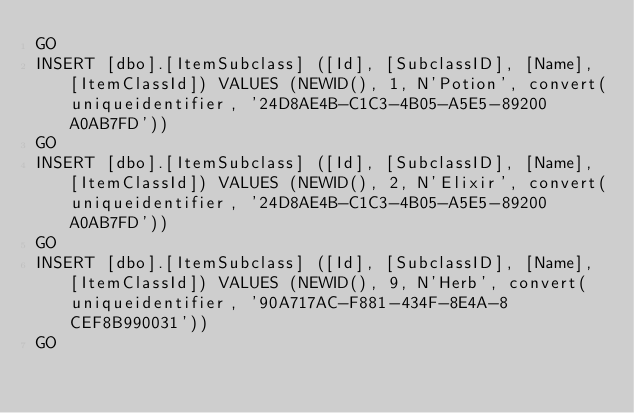<code> <loc_0><loc_0><loc_500><loc_500><_SQL_>GO
INSERT [dbo].[ItemSubclass] ([Id], [SubclassID], [Name], [ItemClassId]) VALUES (NEWID(), 1, N'Potion', convert(uniqueidentifier, '24D8AE4B-C1C3-4B05-A5E5-89200A0AB7FD'))
GO
INSERT [dbo].[ItemSubclass] ([Id], [SubclassID], [Name], [ItemClassId]) VALUES (NEWID(), 2, N'Elixir', convert(uniqueidentifier, '24D8AE4B-C1C3-4B05-A5E5-89200A0AB7FD'))
GO
INSERT [dbo].[ItemSubclass] ([Id], [SubclassID], [Name], [ItemClassId]) VALUES (NEWID(), 9, N'Herb', convert(uniqueidentifier, '90A717AC-F881-434F-8E4A-8CEF8B990031'))
GO</code> 